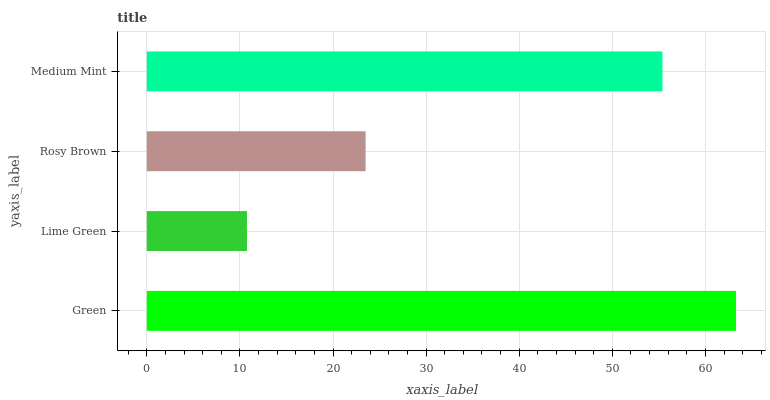Is Lime Green the minimum?
Answer yes or no. Yes. Is Green the maximum?
Answer yes or no. Yes. Is Rosy Brown the minimum?
Answer yes or no. No. Is Rosy Brown the maximum?
Answer yes or no. No. Is Rosy Brown greater than Lime Green?
Answer yes or no. Yes. Is Lime Green less than Rosy Brown?
Answer yes or no. Yes. Is Lime Green greater than Rosy Brown?
Answer yes or no. No. Is Rosy Brown less than Lime Green?
Answer yes or no. No. Is Medium Mint the high median?
Answer yes or no. Yes. Is Rosy Brown the low median?
Answer yes or no. Yes. Is Green the high median?
Answer yes or no. No. Is Lime Green the low median?
Answer yes or no. No. 